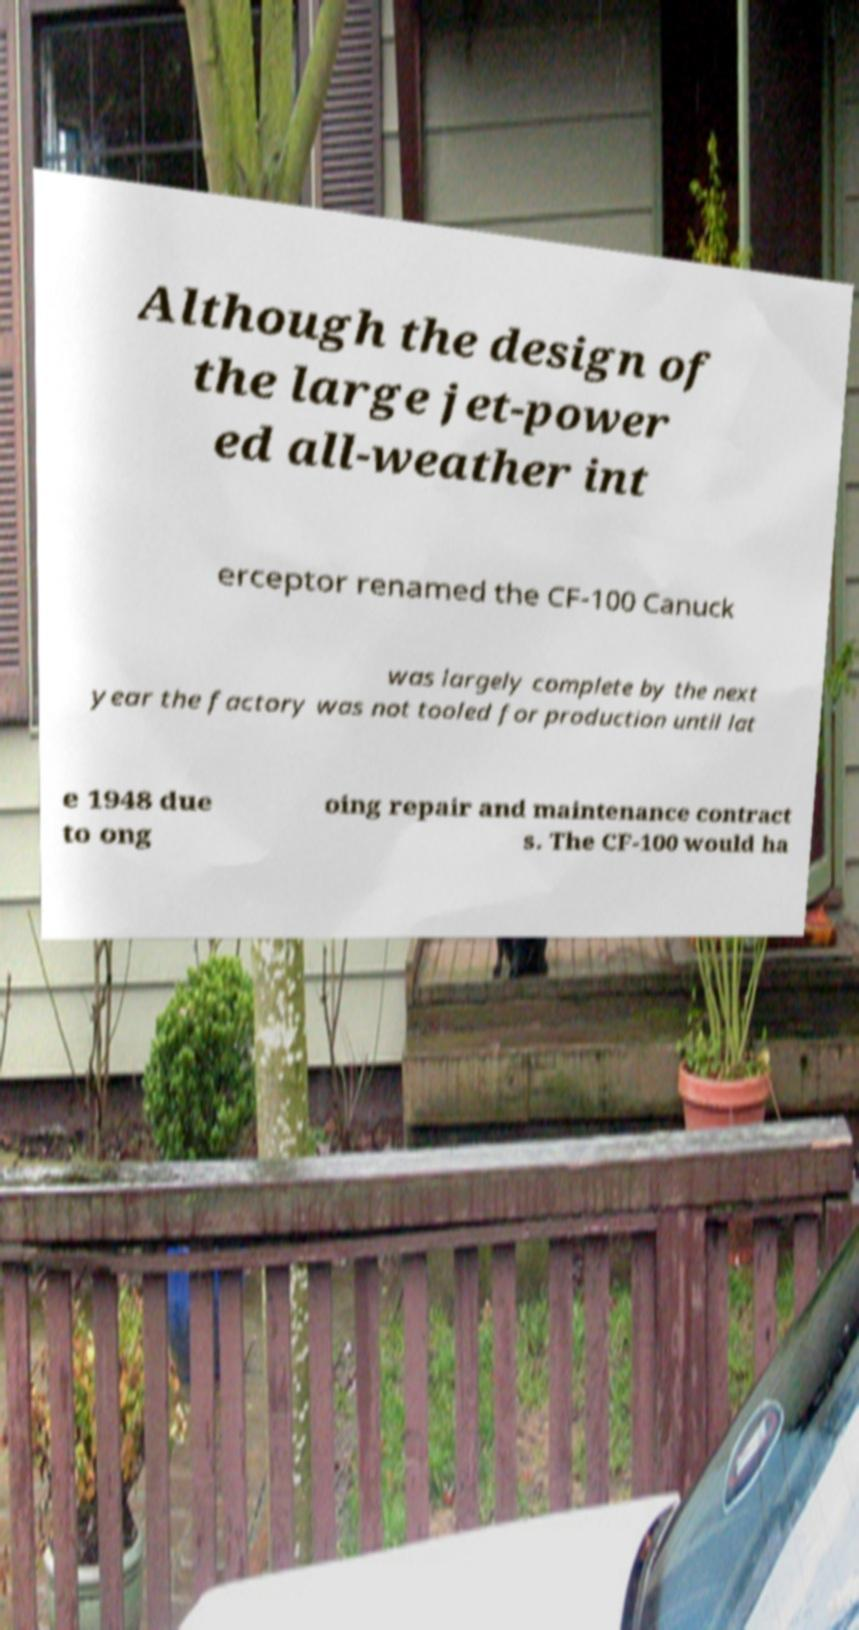For documentation purposes, I need the text within this image transcribed. Could you provide that? Although the design of the large jet-power ed all-weather int erceptor renamed the CF-100 Canuck was largely complete by the next year the factory was not tooled for production until lat e 1948 due to ong oing repair and maintenance contract s. The CF-100 would ha 